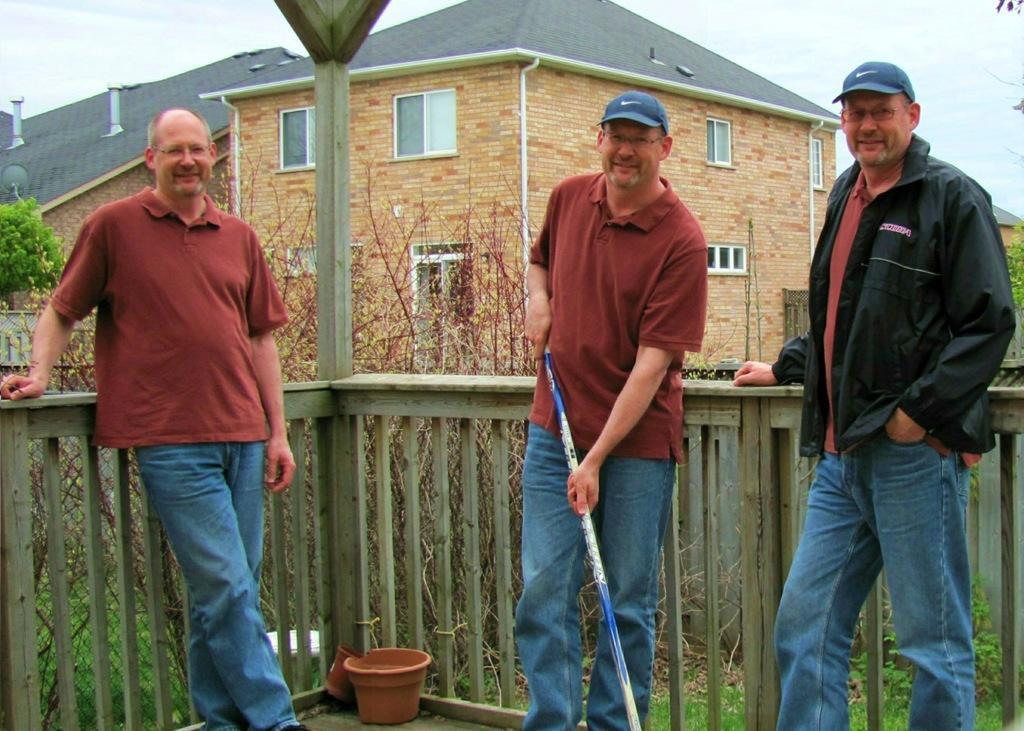Can you describe this image briefly? In the image few people are standing. Behind them there is fencing. Behind the fencing there is grass and trees. At the top of the image there are some buildings. Behind the buildings there are some clouds and sky. 